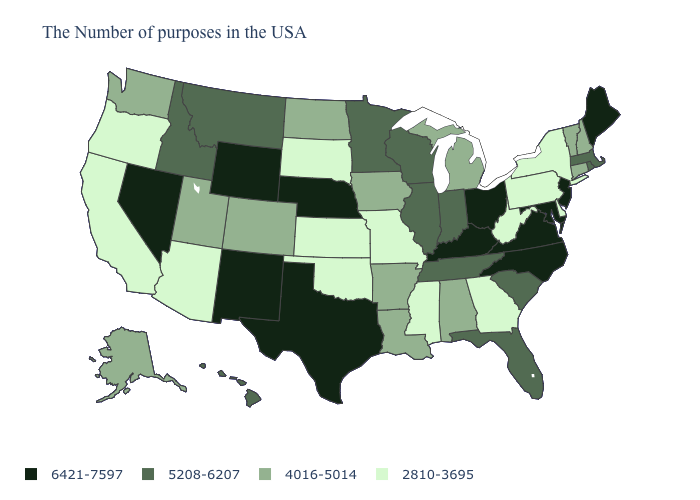Name the states that have a value in the range 6421-7597?
Quick response, please. Maine, New Jersey, Maryland, Virginia, North Carolina, Ohio, Kentucky, Nebraska, Texas, Wyoming, New Mexico, Nevada. What is the value of Florida?
Give a very brief answer. 5208-6207. Which states have the lowest value in the USA?
Give a very brief answer. New York, Delaware, Pennsylvania, West Virginia, Georgia, Mississippi, Missouri, Kansas, Oklahoma, South Dakota, Arizona, California, Oregon. Is the legend a continuous bar?
Quick response, please. No. Does Iowa have a higher value than New Hampshire?
Answer briefly. No. Which states have the lowest value in the USA?
Write a very short answer. New York, Delaware, Pennsylvania, West Virginia, Georgia, Mississippi, Missouri, Kansas, Oklahoma, South Dakota, Arizona, California, Oregon. How many symbols are there in the legend?
Give a very brief answer. 4. Which states have the lowest value in the South?
Write a very short answer. Delaware, West Virginia, Georgia, Mississippi, Oklahoma. Does Illinois have the same value as Minnesota?
Answer briefly. Yes. Does Texas have the highest value in the USA?
Write a very short answer. Yes. What is the value of Hawaii?
Concise answer only. 5208-6207. Does Idaho have the same value as Rhode Island?
Write a very short answer. Yes. What is the lowest value in states that border Nevada?
Short answer required. 2810-3695. What is the value of Minnesota?
Keep it brief. 5208-6207. What is the value of New Hampshire?
Concise answer only. 4016-5014. 